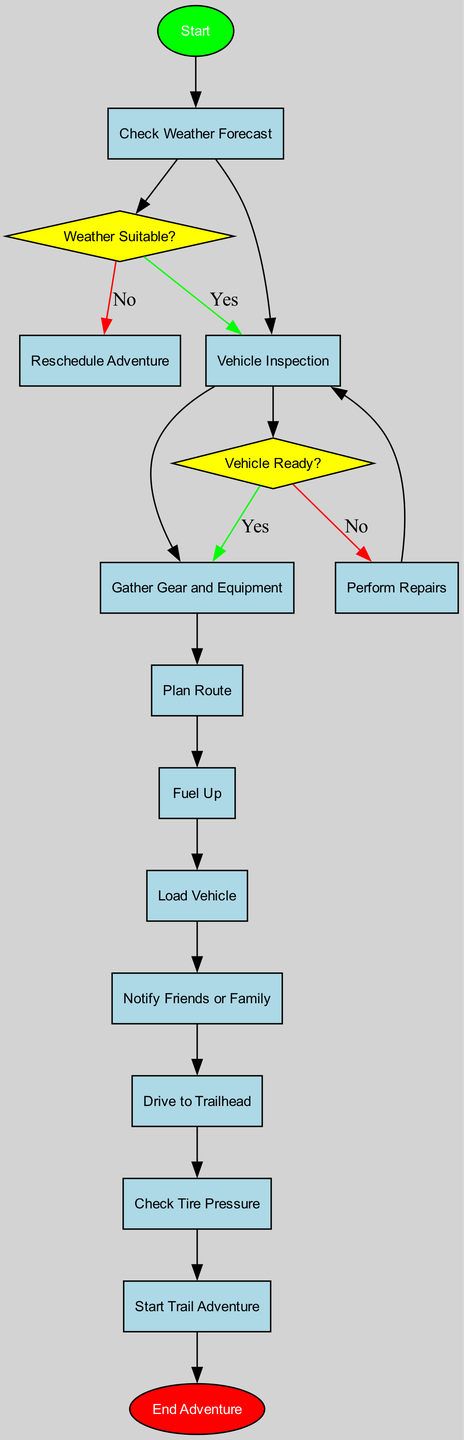What is the first activity in the diagram? The first node after the Start node is labeled "Check Weather Forecast". Therefore, the first activity in the diagram is this node.
Answer: Check Weather Forecast How many total activities are listed in the diagram? There are ten activities listed in the diagram, each representing a different part of the off-road vehicle preparation process.
Answer: Ten What decision is made after checking the weather forecast? After checking the weather forecast, the decision made is labeled "Weather Suitable?" determining if conditions are favorable for off-roading.
Answer: Weather Suitable? What action is taken if the vehicle is not ready? If the vehicle is not ready, the action to be taken is labeled "Perform Repairs", indicating that necessary repairs need to be conducted.
Answer: Perform Repairs What happens if the weather is not suitable? If the weather is not suitable after the decision is made, the next action is "Reschedule Adventure", meaning plans must be changed.
Answer: Reschedule Adventure Which activity follows the "Drive to Trailhead"? After "Drive to Trailhead", the next activity in sequence is "Check Tire Pressure", which ensures the vehicle is ready before starting the adventure.
Answer: Check Tire Pressure How many edges connect to the "Vehicle Inspection" decision? There are two edges connecting to the "Vehicle Inspection" decision: "Yes" leading to "Gather Gear and Equipment" and "No" leading to "Perform Repairs", indicating the decision's outcomes.
Answer: Two What is the status of the 'End Adventure' node? The 'End Adventure' node is labeled as an end point in the diagram, marking the conclusion of the off-road preparation process and adventure.
Answer: End Adventure What links the start node to the first activity? The start node is linked to the first activity, "Check Weather Forecast," by a directed edge representing the progress of the preparation process.
Answer: Check Weather Forecast 